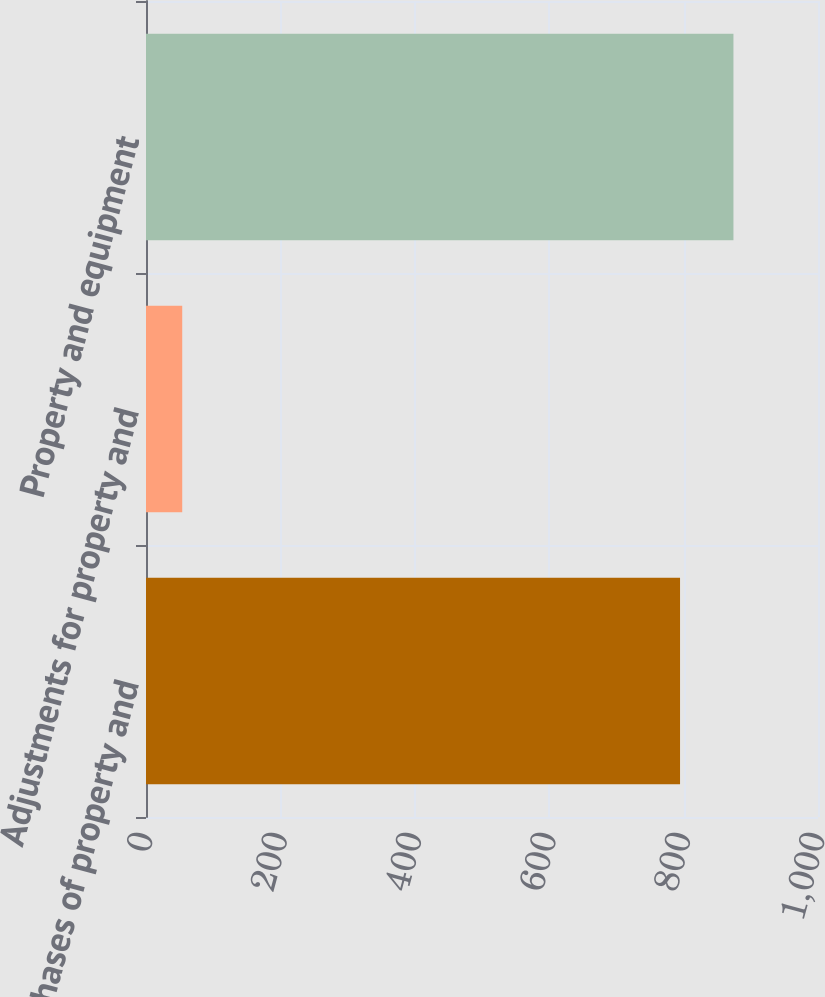Convert chart to OTSL. <chart><loc_0><loc_0><loc_500><loc_500><bar_chart><fcel>Purchases of property and<fcel>Adjustments for property and<fcel>Property and equipment<nl><fcel>794.7<fcel>53.9<fcel>874.17<nl></chart> 